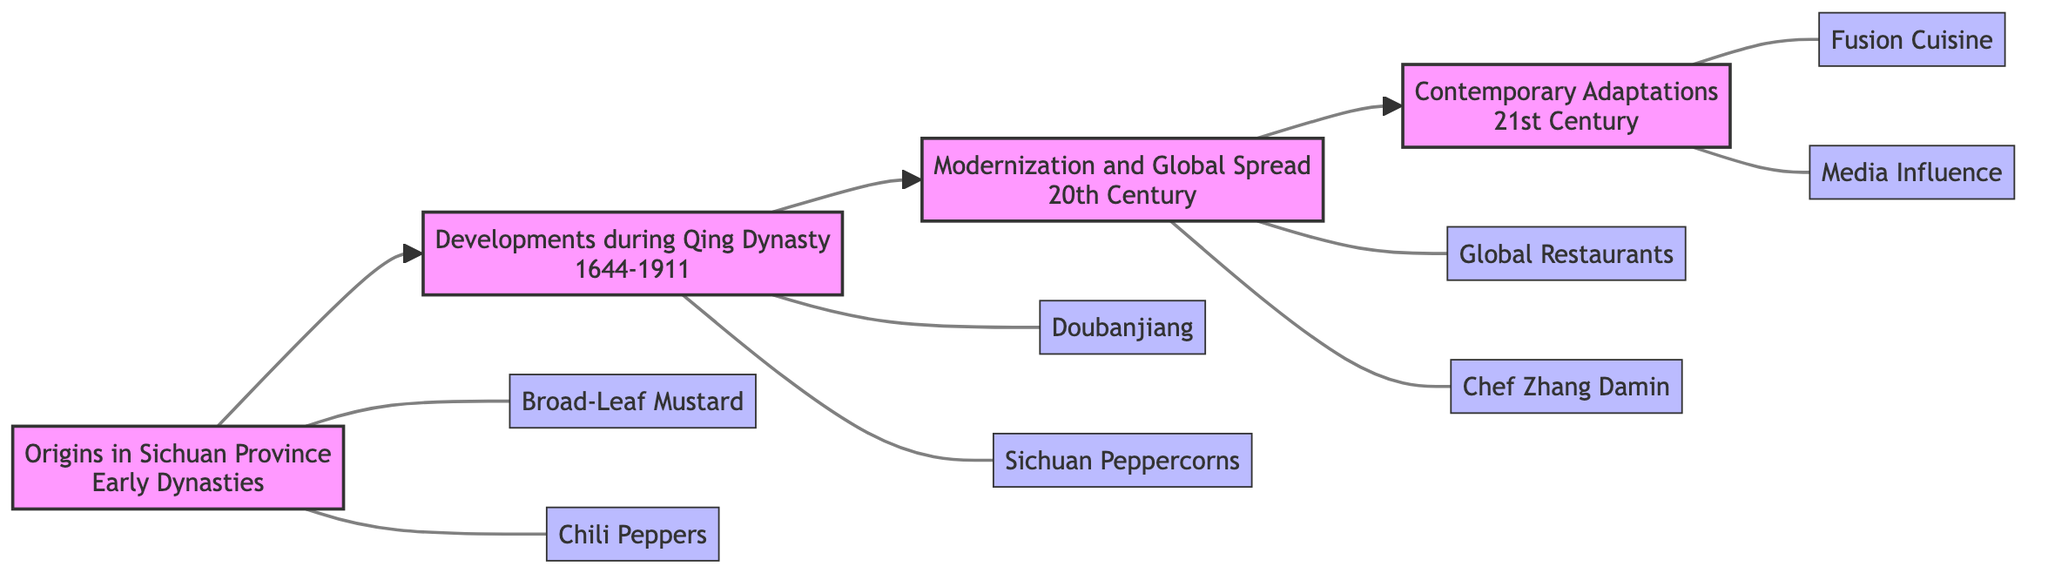What is the first phase in the historical journey of Sichuan cuisine? The diagram indicates that the first phase is "Origins in Sichuan Province." This is at the far left of the flowchart, representing the starting point.
Answer: Origins in Sichuan Province How many key contributions are listed in the "Developments during Qing Dynasty" phase? By examining the second phase of the flowchart, "Developments during Qing Dynasty," there are two key contributions indicated: Doubanjiang Creation and Usage of Sichuan Peppercorns.
Answer: 2 Which culinary influence is associated with the 21st Century adaptations of Sichuan cuisine? The phase labeled "Contemporary Adaptations" in the flowchart shows that "Media and Pop Culture Influence" is one of the key contributions, specifically emphasizing the role of modern channels in promoting Sichuan cuisine.
Answer: Media and Pop Culture Influence What ingredient was introduced to Sichuan cuisine via the Columbian Exchange? In the "Origins in Sichuan Province" phase, the diagram mentions "Chili Peppers Introduction," which indicates that chili peppers were brought to China through the Columbian Exchange and quickly became part of Sichuan cuisine.
Answer: Chili Peppers What is the relationship between "Modernization and Global Spread" and "Contemporary Adaptations"? The flowchart visually shows that "Modernization and Global Spread" is followed directly by "Contemporary Adaptations," indicating a sequential development from the global recognition of Sichuan cuisine to its modern interpretations and adaptations.
Answer: Sequential development How many key contributions are associated with "Origins in Sichuan Province"? Looking at the "Origins in Sichuan Province" phase, there are two key contributions outlined: Broad-Leaf Mustard and Chili Peppers, which means there is a total of two contributions mentioned.
Answer: 2 What is the primary contribution during the Qing Dynasty that became central to Sichuan cuisine? The "Doubanjiang Creation" is specifically highlighted in the "Developments during Qing Dynasty" phase as a primary contribution that became essential for flavor profiles in Sichuan cuisine.
Answer: Doubanjiang Creation Which chef popularized Sichuan dishes abroad in the 20th Century? In the "Modernization and Global Spread" phase, "Influence of Chef Zhang Damin" is noted as a significant contributor to the popularity of Sichuan dishes internationally, particularly in the USA.
Answer: Chef Zhang Damin What aspect of cuisine is emphasized in the 21st Century besides fusion? According to the "Contemporary Adaptations" phase, both "Fusion Cuisine" and "Media Influence" are key contributions, indicating that the role of media and pop culture is another aspect highlighted in the 21st century.
Answer: Media Influence 